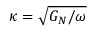Convert formula to latex. <formula><loc_0><loc_0><loc_500><loc_500>\kappa = { \sqrt { G _ { N } / \omega } }</formula> 